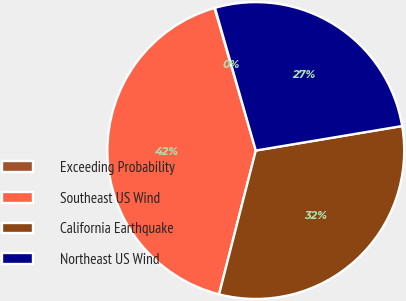<chart> <loc_0><loc_0><loc_500><loc_500><pie_chart><fcel>Exceeding Probability<fcel>Southeast US Wind<fcel>California Earthquake<fcel>Northeast US Wind<nl><fcel>0.06%<fcel>41.52%<fcel>31.62%<fcel>26.79%<nl></chart> 